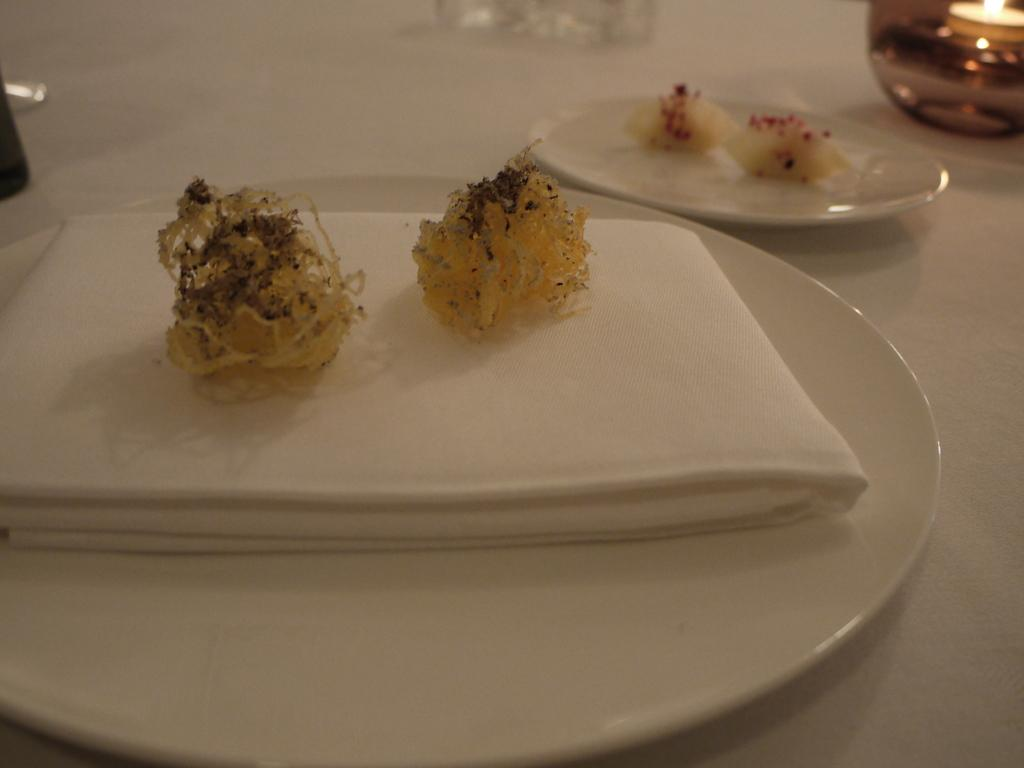What objects can be seen on the plates in the image? The plates contain objects, but the specific objects are not mentioned in the facts. Where is the oil lamp located in the image? The oil lamp is in the top right of the image. What type of haircut is visible on the plates in the image? There is no haircut present on the plates in the image. What sound can be heard from the bells in the image? There are no bells present in the image. 